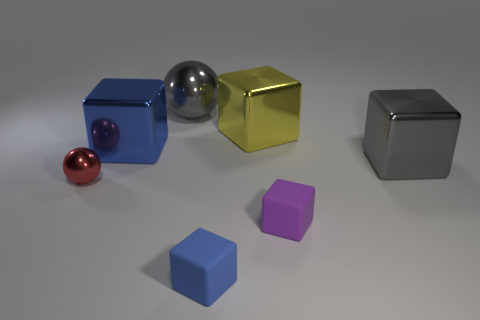Subtract all purple balls. How many blue cubes are left? 2 Subtract all small purple cubes. How many cubes are left? 4 Subtract all purple cubes. How many cubes are left? 4 Subtract 2 blocks. How many blocks are left? 3 Add 2 rubber blocks. How many objects exist? 9 Subtract all green blocks. Subtract all brown spheres. How many blocks are left? 5 Subtract all spheres. How many objects are left? 5 Add 3 shiny objects. How many shiny objects are left? 8 Add 4 red shiny objects. How many red shiny objects exist? 5 Subtract 0 brown cylinders. How many objects are left? 7 